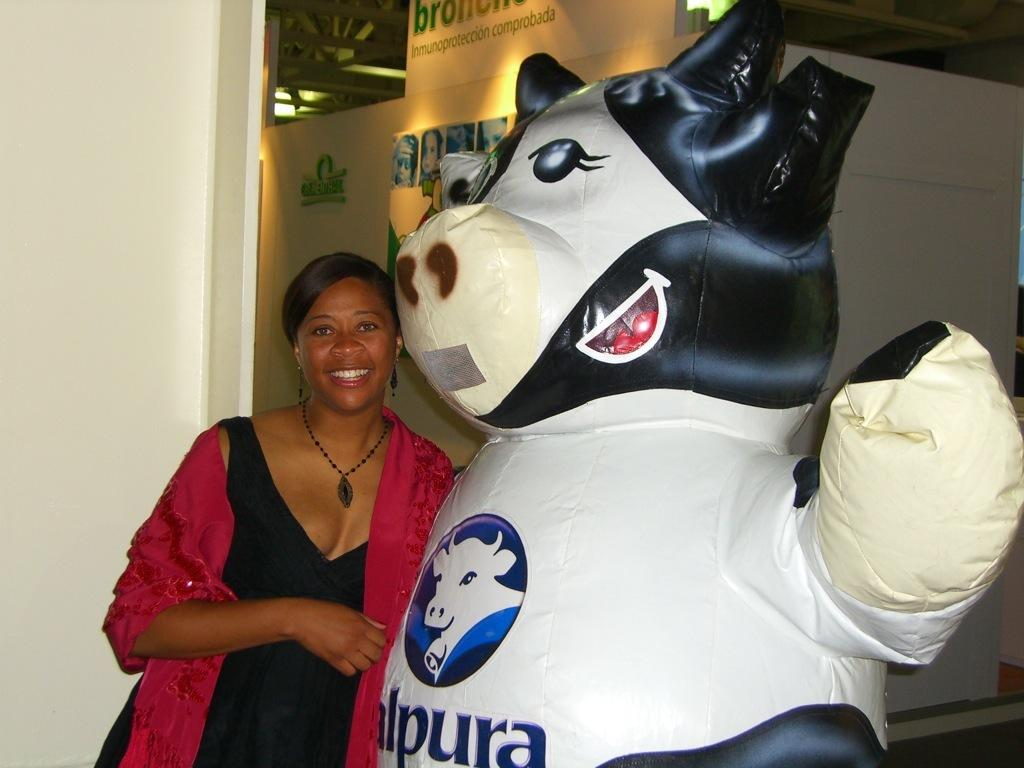Provide a one-sentence caption for the provided image. a woman next to a cow figure with letter l, p, u, r and a on its chest. 